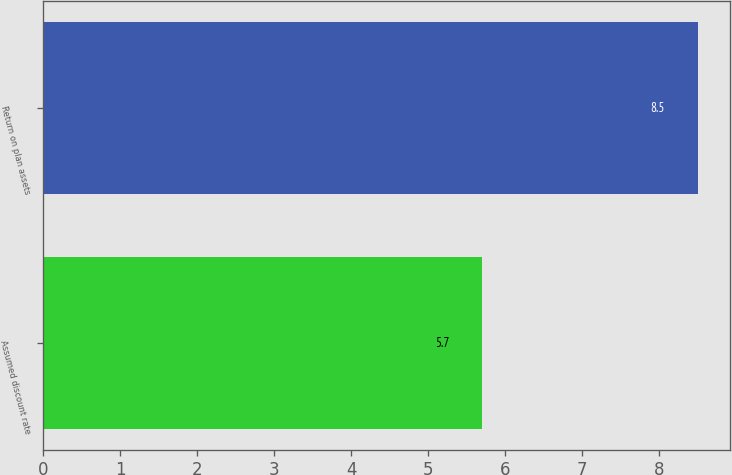Convert chart. <chart><loc_0><loc_0><loc_500><loc_500><bar_chart><fcel>Assumed discount rate<fcel>Return on plan assets<nl><fcel>5.7<fcel>8.5<nl></chart> 